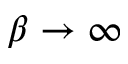Convert formula to latex. <formula><loc_0><loc_0><loc_500><loc_500>\beta \to \infty</formula> 